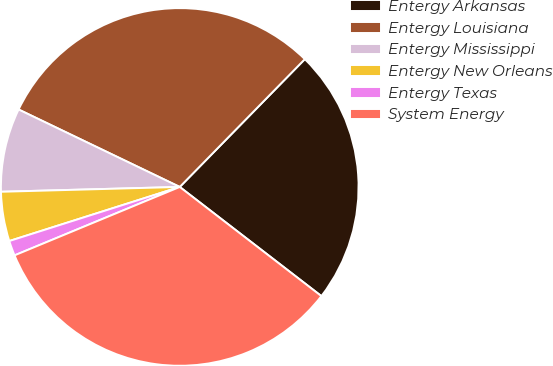Convert chart. <chart><loc_0><loc_0><loc_500><loc_500><pie_chart><fcel>Entergy Arkansas<fcel>Entergy Louisiana<fcel>Entergy Mississippi<fcel>Entergy New Orleans<fcel>Entergy Texas<fcel>System Energy<nl><fcel>23.12%<fcel>30.2%<fcel>7.56%<fcel>4.46%<fcel>1.36%<fcel>33.3%<nl></chart> 